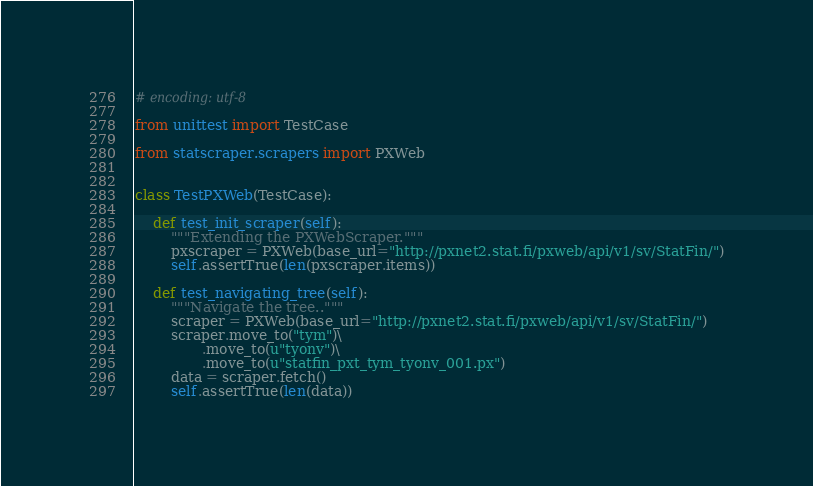Convert code to text. <code><loc_0><loc_0><loc_500><loc_500><_Python_># encoding: utf-8

from unittest import TestCase

from statscraper.scrapers import PXWeb


class TestPXWeb(TestCase):

    def test_init_scraper(self):
        """Extending the PXWebScraper."""
        pxscraper = PXWeb(base_url="http://pxnet2.stat.fi/pxweb/api/v1/sv/StatFin/")
        self.assertTrue(len(pxscraper.items))

    def test_navigating_tree(self):
        """Navigate the tree.."""
        scraper = PXWeb(base_url="http://pxnet2.stat.fi/pxweb/api/v1/sv/StatFin/")
        scraper.move_to("tym")\
               .move_to(u"tyonv")\
               .move_to(u"statfin_pxt_tym_tyonv_001.px")
        data = scraper.fetch()
        self.assertTrue(len(data))
</code> 